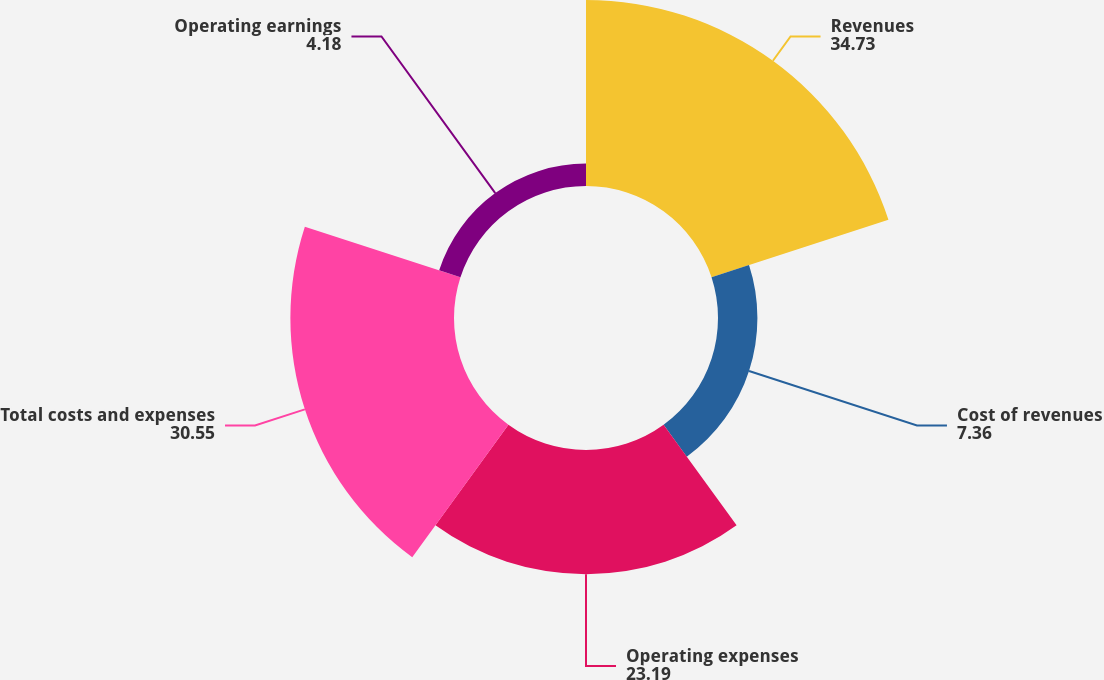Convert chart to OTSL. <chart><loc_0><loc_0><loc_500><loc_500><pie_chart><fcel>Revenues<fcel>Cost of revenues<fcel>Operating expenses<fcel>Total costs and expenses<fcel>Operating earnings<nl><fcel>34.73%<fcel>7.36%<fcel>23.19%<fcel>30.55%<fcel>4.18%<nl></chart> 